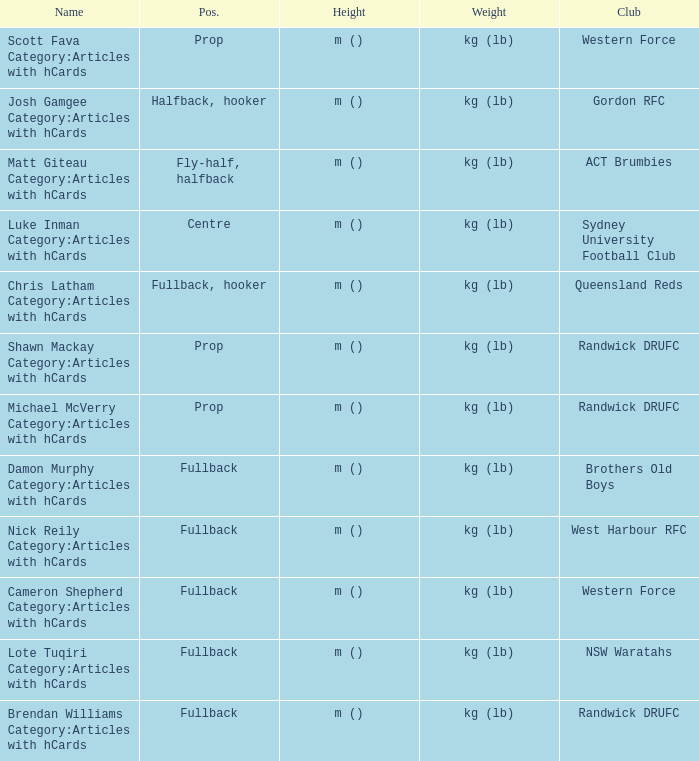What is the name when the position was fullback, hooker? Chris Latham Category:Articles with hCards. 